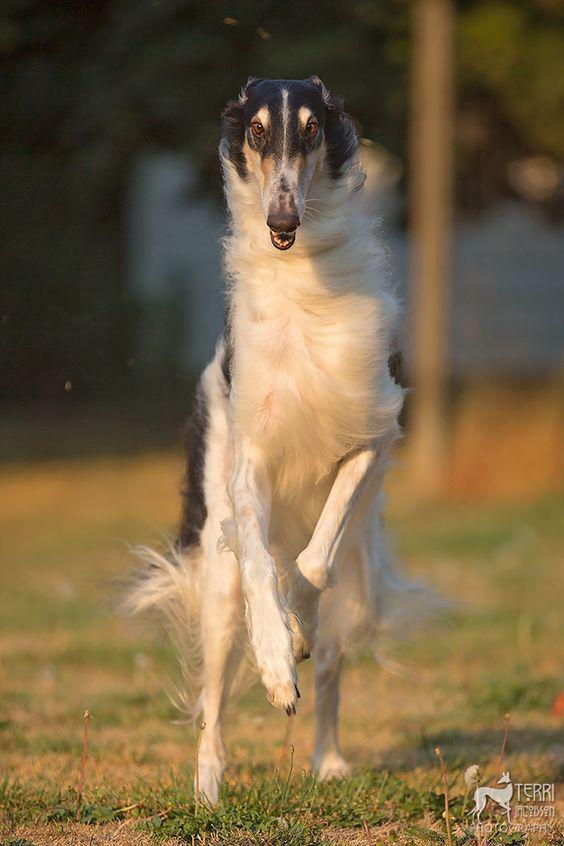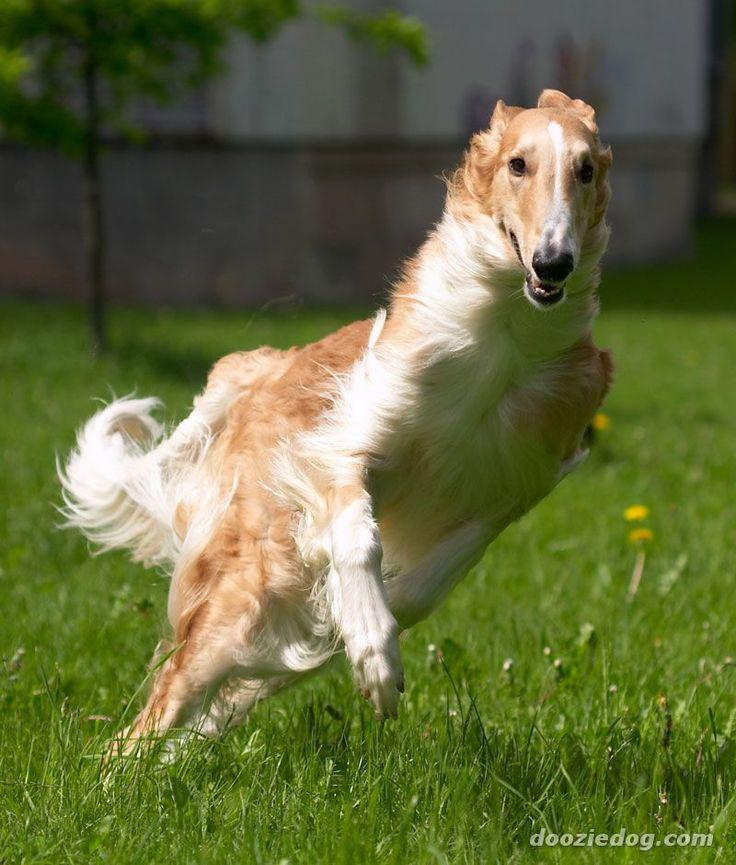The first image is the image on the left, the second image is the image on the right. Examine the images to the left and right. Is the description "In total, at least two dogs are bounding across a field with front paws off the ground." accurate? Answer yes or no. Yes. The first image is the image on the left, the second image is the image on the right. Assess this claim about the two images: "The dog in the image on the right is running across the grass to the right side.". Correct or not? Answer yes or no. Yes. 